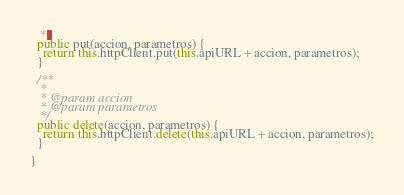<code> <loc_0><loc_0><loc_500><loc_500><_TypeScript_>   */
  public put(accion, parametros) {
    return this.httpClient.put(this.apiURL + accion, parametros);
  }

  /**
   * 
   * @param accion 
   * @param parametros 
   */
  public delete(accion, parametros) {
    return this.httpClient.delete(this.apiURL + accion, parametros);
  }

}
</code> 